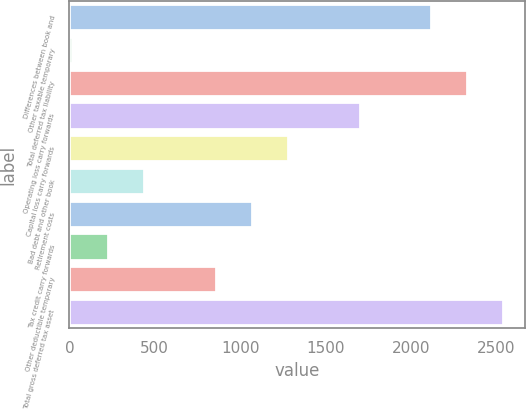Convert chart. <chart><loc_0><loc_0><loc_500><loc_500><bar_chart><fcel>Differences between book and<fcel>Other taxable temporary<fcel>Total deferred tax liability<fcel>Operating loss carry forwards<fcel>Capital loss carry forwards<fcel>Bad debt and other book<fcel>Retirement costs<fcel>Tax credit carry forwards<fcel>Other deductible temporary<fcel>Total gross deferred tax asset<nl><fcel>2121<fcel>14<fcel>2331.7<fcel>1699.6<fcel>1278.2<fcel>435.4<fcel>1067.5<fcel>224.7<fcel>856.8<fcel>2542.4<nl></chart> 